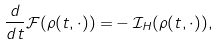Convert formula to latex. <formula><loc_0><loc_0><loc_500><loc_500>\frac { d } { d t } \mathcal { F } ( \rho ( t , \cdot ) ) = & - \mathcal { I } _ { H } ( \rho ( t , \cdot ) ) ,</formula> 